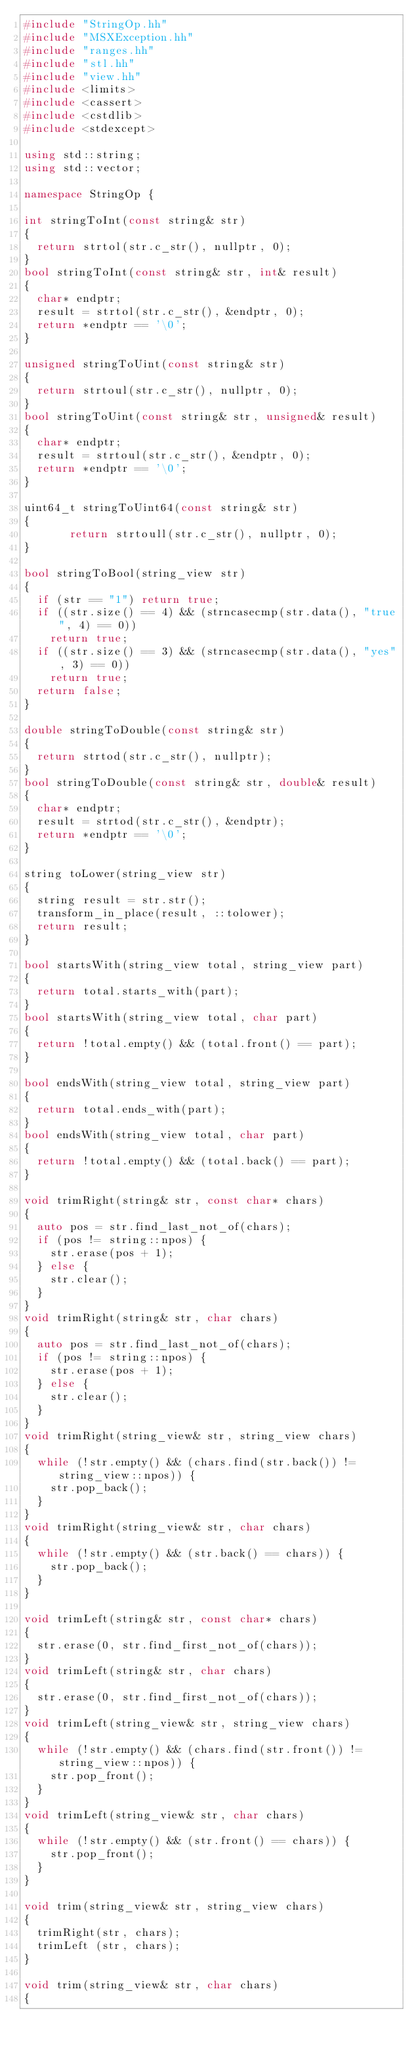<code> <loc_0><loc_0><loc_500><loc_500><_C++_>#include "StringOp.hh"
#include "MSXException.hh"
#include "ranges.hh"
#include "stl.hh"
#include "view.hh"
#include <limits>
#include <cassert>
#include <cstdlib>
#include <stdexcept>

using std::string;
using std::vector;

namespace StringOp {

int stringToInt(const string& str)
{
	return strtol(str.c_str(), nullptr, 0);
}
bool stringToInt(const string& str, int& result)
{
	char* endptr;
	result = strtol(str.c_str(), &endptr, 0);
	return *endptr == '\0';
}

unsigned stringToUint(const string& str)
{
	return strtoul(str.c_str(), nullptr, 0);
}
bool stringToUint(const string& str, unsigned& result)
{
	char* endptr;
	result = strtoul(str.c_str(), &endptr, 0);
	return *endptr == '\0';
}

uint64_t stringToUint64(const string& str)
{
       return strtoull(str.c_str(), nullptr, 0);
}

bool stringToBool(string_view str)
{
	if (str == "1") return true;
	if ((str.size() == 4) && (strncasecmp(str.data(), "true", 4) == 0))
		return true;
	if ((str.size() == 3) && (strncasecmp(str.data(), "yes", 3) == 0))
		return true;
	return false;
}

double stringToDouble(const string& str)
{
	return strtod(str.c_str(), nullptr);
}
bool stringToDouble(const string& str, double& result)
{
	char* endptr;
	result = strtod(str.c_str(), &endptr);
	return *endptr == '\0';
}

string toLower(string_view str)
{
	string result = str.str();
	transform_in_place(result, ::tolower);
	return result;
}

bool startsWith(string_view total, string_view part)
{
	return total.starts_with(part);
}
bool startsWith(string_view total, char part)
{
	return !total.empty() && (total.front() == part);
}

bool endsWith(string_view total, string_view part)
{
	return total.ends_with(part);
}
bool endsWith(string_view total, char part)
{
	return !total.empty() && (total.back() == part);
}

void trimRight(string& str, const char* chars)
{
	auto pos = str.find_last_not_of(chars);
	if (pos != string::npos) {
		str.erase(pos + 1);
	} else {
		str.clear();
	}
}
void trimRight(string& str, char chars)
{
	auto pos = str.find_last_not_of(chars);
	if (pos != string::npos) {
		str.erase(pos + 1);
	} else {
		str.clear();
	}
}
void trimRight(string_view& str, string_view chars)
{
	while (!str.empty() && (chars.find(str.back()) != string_view::npos)) {
		str.pop_back();
	}
}
void trimRight(string_view& str, char chars)
{
	while (!str.empty() && (str.back() == chars)) {
		str.pop_back();
	}
}

void trimLeft(string& str, const char* chars)
{
	str.erase(0, str.find_first_not_of(chars));
}
void trimLeft(string& str, char chars)
{
	str.erase(0, str.find_first_not_of(chars));
}
void trimLeft(string_view& str, string_view chars)
{
	while (!str.empty() && (chars.find(str.front()) != string_view::npos)) {
		str.pop_front();
	}
}
void trimLeft(string_view& str, char chars)
{
	while (!str.empty() && (str.front() == chars)) {
		str.pop_front();
	}
}

void trim(string_view& str, string_view chars)
{
	trimRight(str, chars);
	trimLeft (str, chars);
}

void trim(string_view& str, char chars)
{</code> 